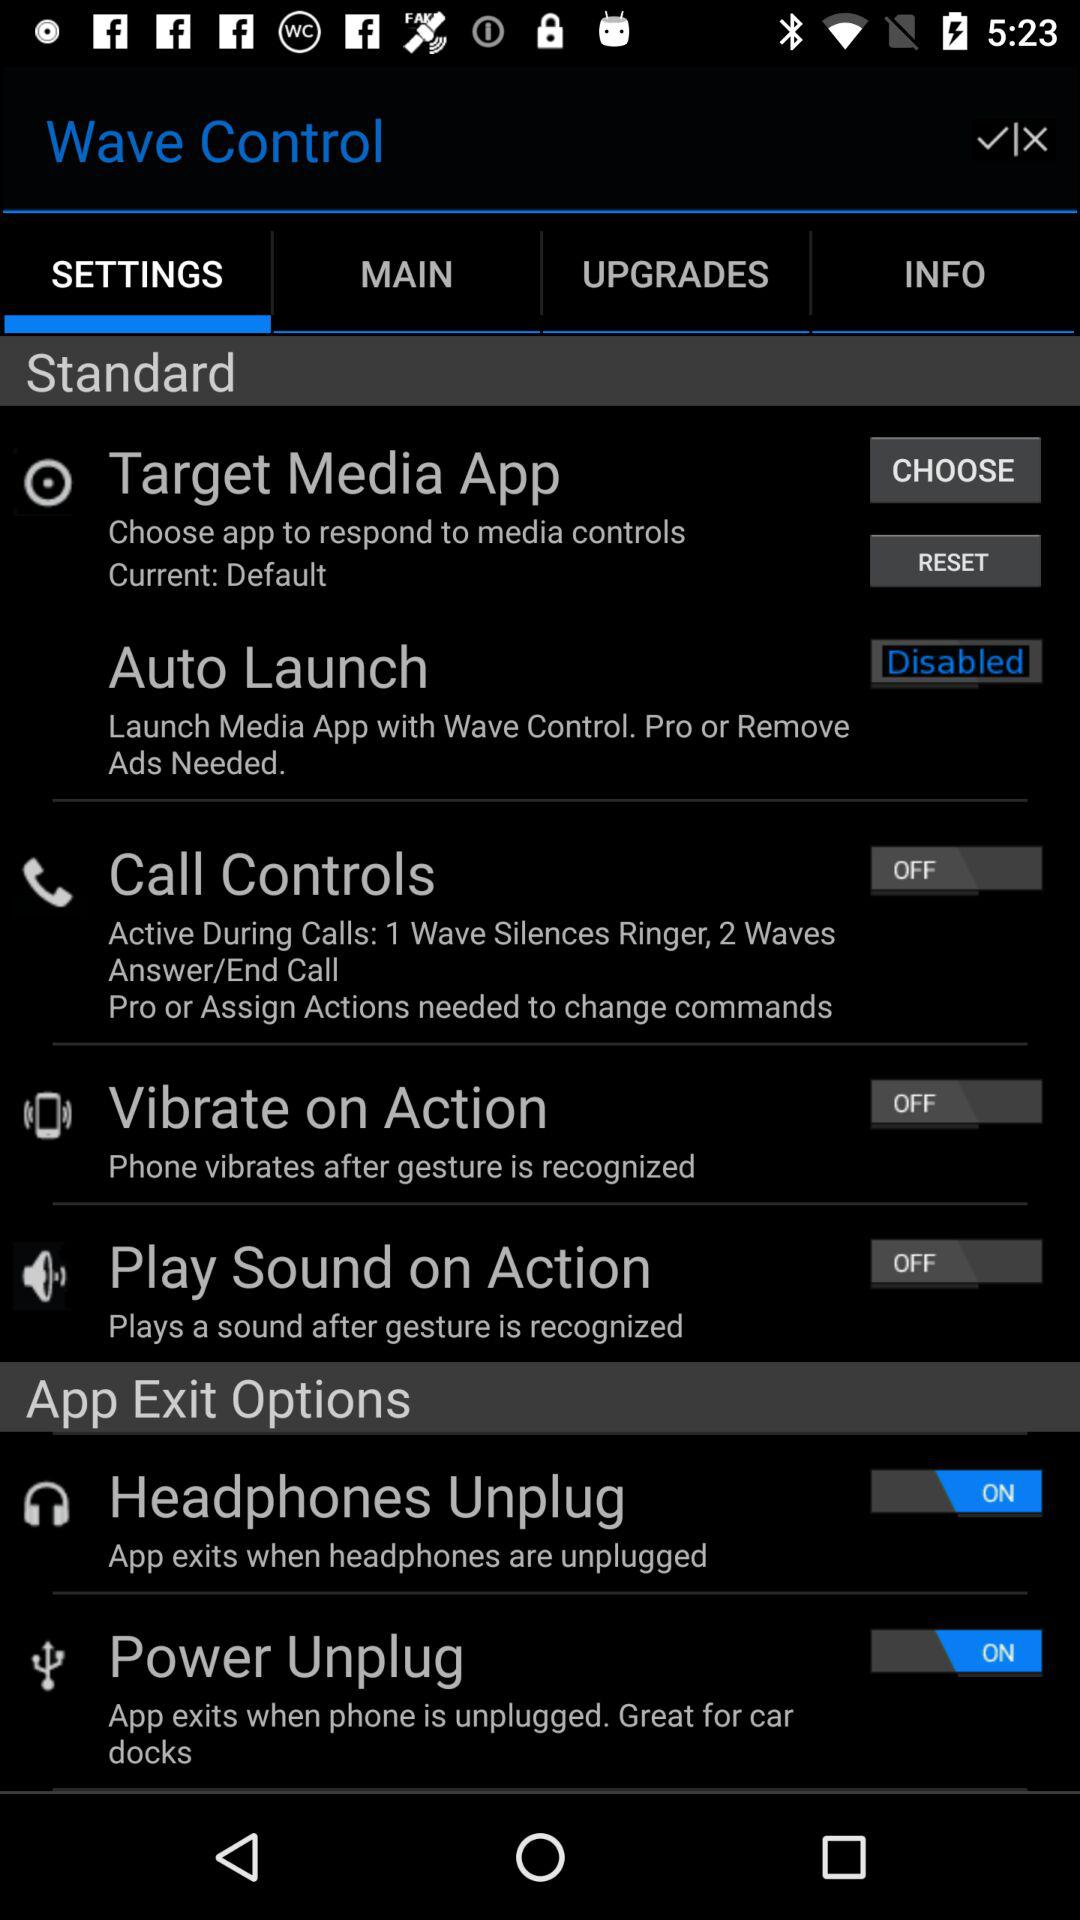What is the function of the 'Headphones Unplug' feature? The 'Headphones Unplug' feature automatically exits the app when headphones are unplugged from the device, which is practical for preventing audio from playing out loud unexpectedly. 